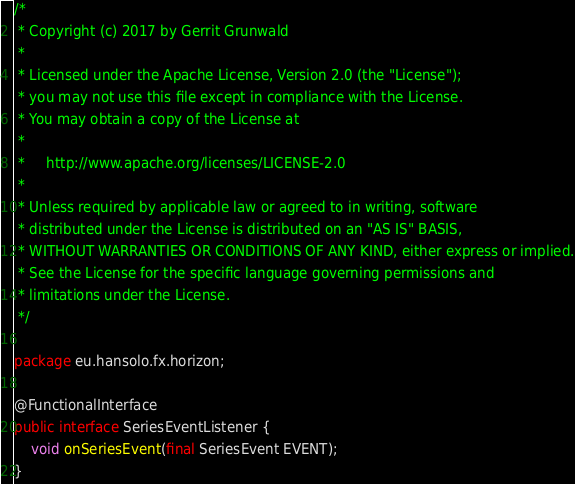Convert code to text. <code><loc_0><loc_0><loc_500><loc_500><_Java_>/*
 * Copyright (c) 2017 by Gerrit Grunwald
 *
 * Licensed under the Apache License, Version 2.0 (the "License");
 * you may not use this file except in compliance with the License.
 * You may obtain a copy of the License at
 *
 *     http://www.apache.org/licenses/LICENSE-2.0
 *
 * Unless required by applicable law or agreed to in writing, software
 * distributed under the License is distributed on an "AS IS" BASIS,
 * WITHOUT WARRANTIES OR CONDITIONS OF ANY KIND, either express or implied.
 * See the License for the specific language governing permissions and
 * limitations under the License.
 */

package eu.hansolo.fx.horizon;

@FunctionalInterface
public interface SeriesEventListener {
    void onSeriesEvent(final SeriesEvent EVENT);
}
</code> 